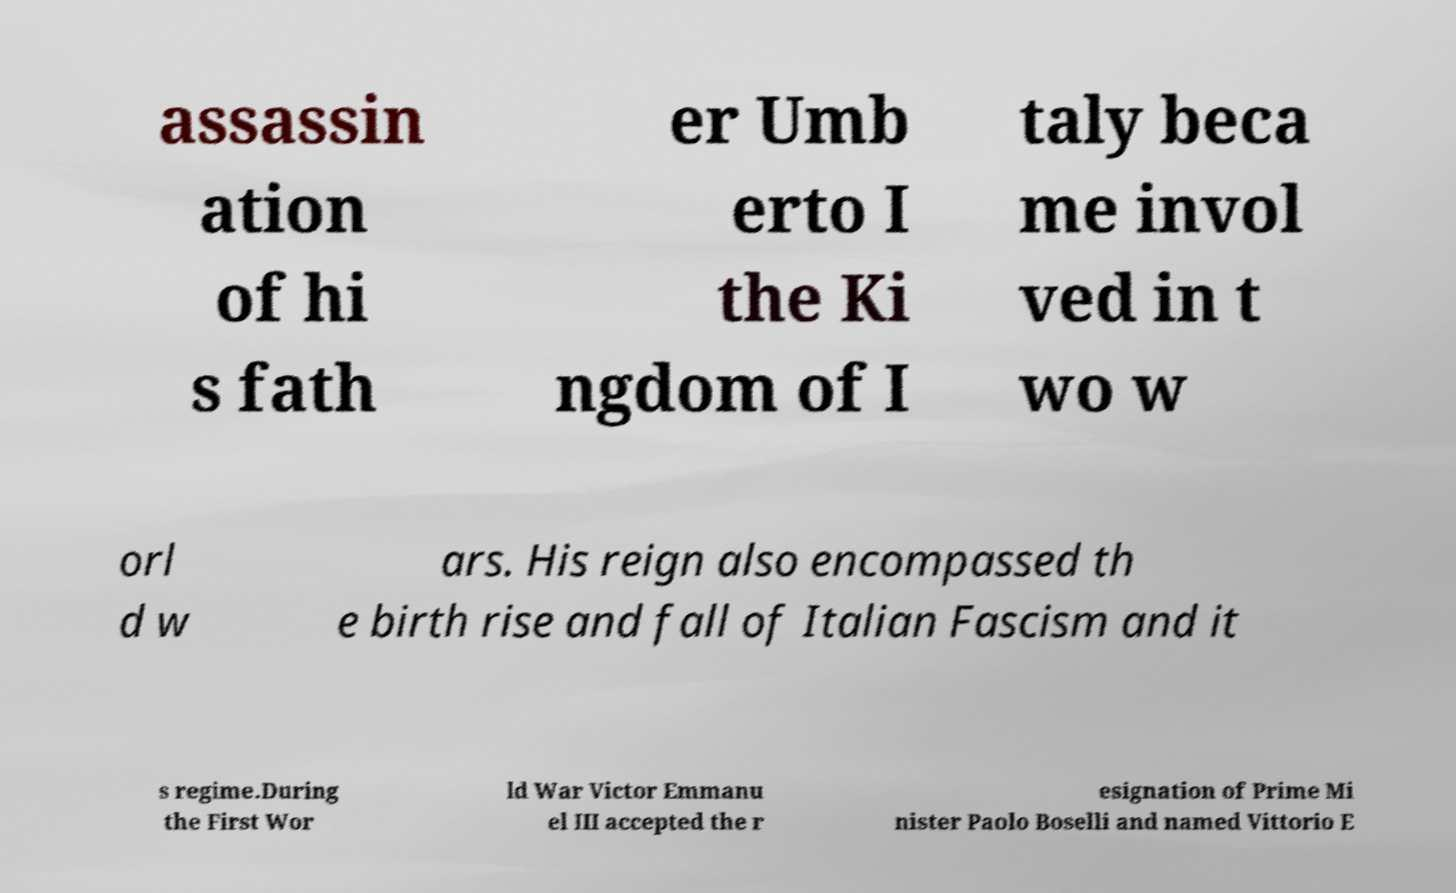There's text embedded in this image that I need extracted. Can you transcribe it verbatim? assassin ation of hi s fath er Umb erto I the Ki ngdom of I taly beca me invol ved in t wo w orl d w ars. His reign also encompassed th e birth rise and fall of Italian Fascism and it s regime.During the First Wor ld War Victor Emmanu el III accepted the r esignation of Prime Mi nister Paolo Boselli and named Vittorio E 